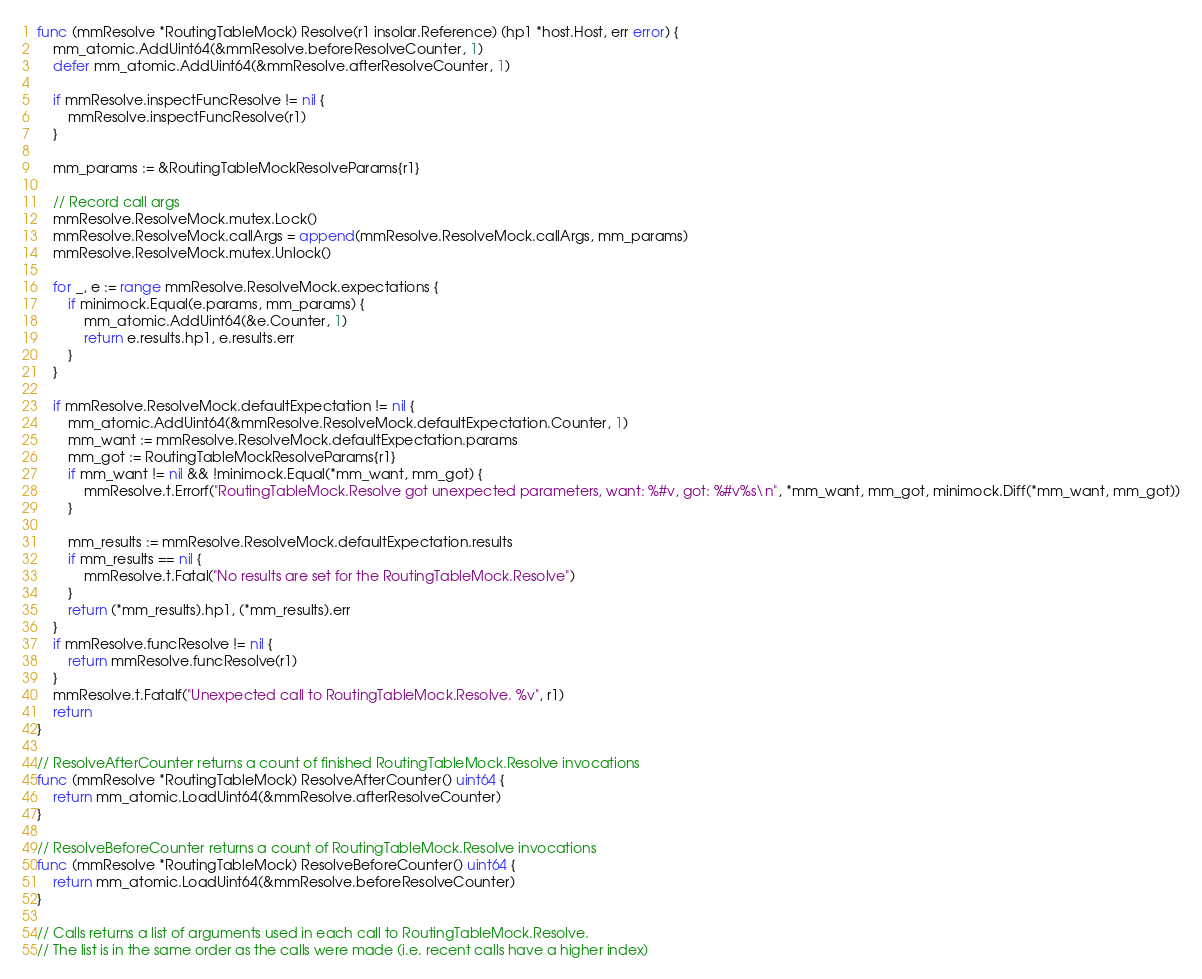Convert code to text. <code><loc_0><loc_0><loc_500><loc_500><_Go_>func (mmResolve *RoutingTableMock) Resolve(r1 insolar.Reference) (hp1 *host.Host, err error) {
	mm_atomic.AddUint64(&mmResolve.beforeResolveCounter, 1)
	defer mm_atomic.AddUint64(&mmResolve.afterResolveCounter, 1)

	if mmResolve.inspectFuncResolve != nil {
		mmResolve.inspectFuncResolve(r1)
	}

	mm_params := &RoutingTableMockResolveParams{r1}

	// Record call args
	mmResolve.ResolveMock.mutex.Lock()
	mmResolve.ResolveMock.callArgs = append(mmResolve.ResolveMock.callArgs, mm_params)
	mmResolve.ResolveMock.mutex.Unlock()

	for _, e := range mmResolve.ResolveMock.expectations {
		if minimock.Equal(e.params, mm_params) {
			mm_atomic.AddUint64(&e.Counter, 1)
			return e.results.hp1, e.results.err
		}
	}

	if mmResolve.ResolveMock.defaultExpectation != nil {
		mm_atomic.AddUint64(&mmResolve.ResolveMock.defaultExpectation.Counter, 1)
		mm_want := mmResolve.ResolveMock.defaultExpectation.params
		mm_got := RoutingTableMockResolveParams{r1}
		if mm_want != nil && !minimock.Equal(*mm_want, mm_got) {
			mmResolve.t.Errorf("RoutingTableMock.Resolve got unexpected parameters, want: %#v, got: %#v%s\n", *mm_want, mm_got, minimock.Diff(*mm_want, mm_got))
		}

		mm_results := mmResolve.ResolveMock.defaultExpectation.results
		if mm_results == nil {
			mmResolve.t.Fatal("No results are set for the RoutingTableMock.Resolve")
		}
		return (*mm_results).hp1, (*mm_results).err
	}
	if mmResolve.funcResolve != nil {
		return mmResolve.funcResolve(r1)
	}
	mmResolve.t.Fatalf("Unexpected call to RoutingTableMock.Resolve. %v", r1)
	return
}

// ResolveAfterCounter returns a count of finished RoutingTableMock.Resolve invocations
func (mmResolve *RoutingTableMock) ResolveAfterCounter() uint64 {
	return mm_atomic.LoadUint64(&mmResolve.afterResolveCounter)
}

// ResolveBeforeCounter returns a count of RoutingTableMock.Resolve invocations
func (mmResolve *RoutingTableMock) ResolveBeforeCounter() uint64 {
	return mm_atomic.LoadUint64(&mmResolve.beforeResolveCounter)
}

// Calls returns a list of arguments used in each call to RoutingTableMock.Resolve.
// The list is in the same order as the calls were made (i.e. recent calls have a higher index)</code> 